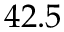Convert formula to latex. <formula><loc_0><loc_0><loc_500><loc_500>4 2 . 5</formula> 